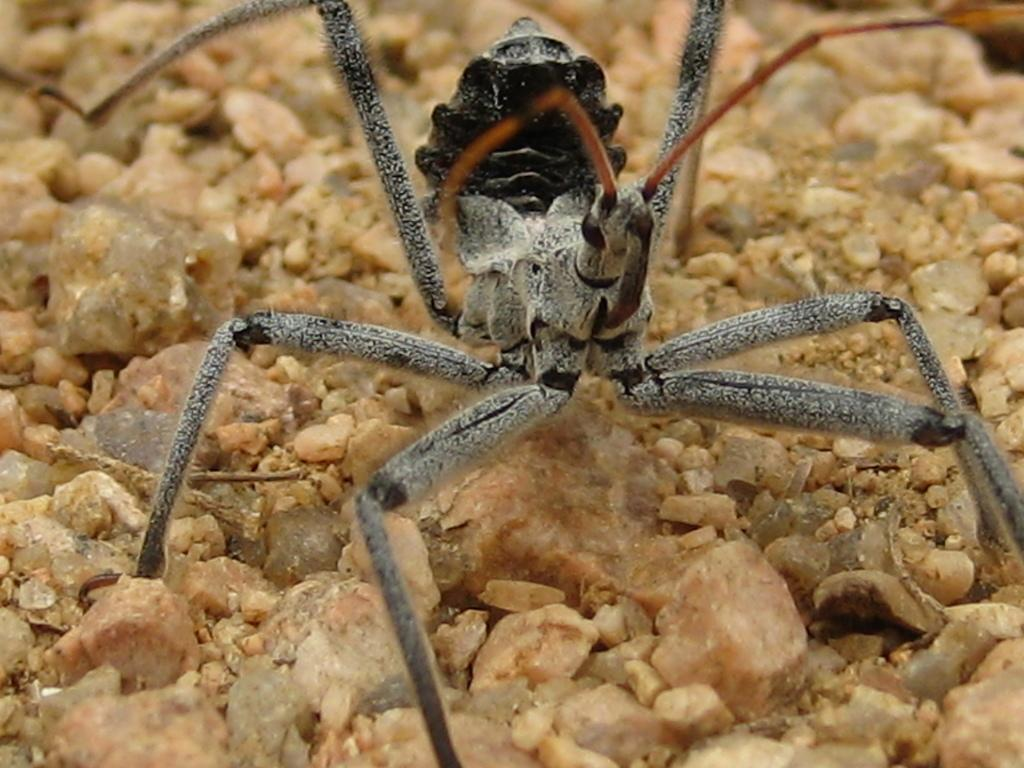What type of creature is in the picture? There is an insect in the picture. Can you describe the colors of the insect? The insect has grey, black, and red colors. How many legs does the insect have? The insect has six legs. What can be seen at the bottom of the image? There are stones visible at the bottom of the image. What type of event is taking place in the image? There is no event present in the image; it features an insect with a description of its colors and legs, as well as stones at the bottom. Can you tell me how many balls are visible in the image? There are no balls present in the image. 